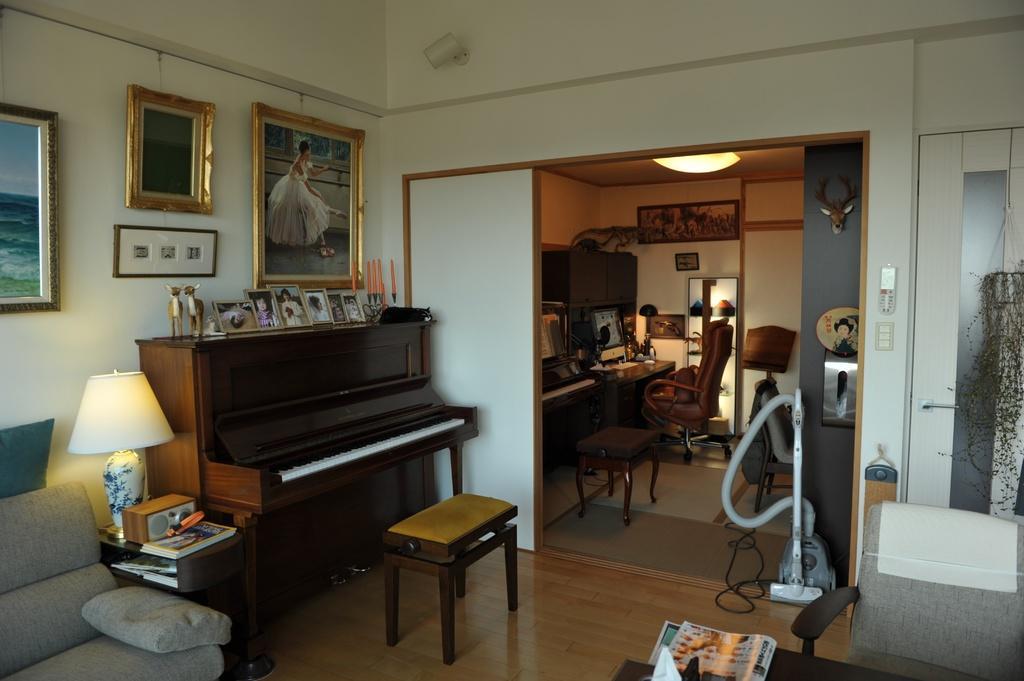In one or two sentences, can you explain what this image depicts? Here I can see a piano with a small stool in front of the piano. There are photo frames,toys,and a candle stand placed on the piano desk. Here is a small tea pot with some books,lamp and some object placed on it. These are the photo frames attached to the wall. This is a couch which is grey in color. This looks like another small room. I can see chairs and stool. This is a small desk with some objects placed on it. This is a lamp which is attached to the rooftop. And here is the vacuum cleaner. 